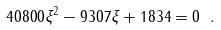Convert formula to latex. <formula><loc_0><loc_0><loc_500><loc_500>4 0 8 0 0 \xi ^ { 2 } - 9 3 0 7 \xi + 1 8 3 4 = 0 \ .</formula> 